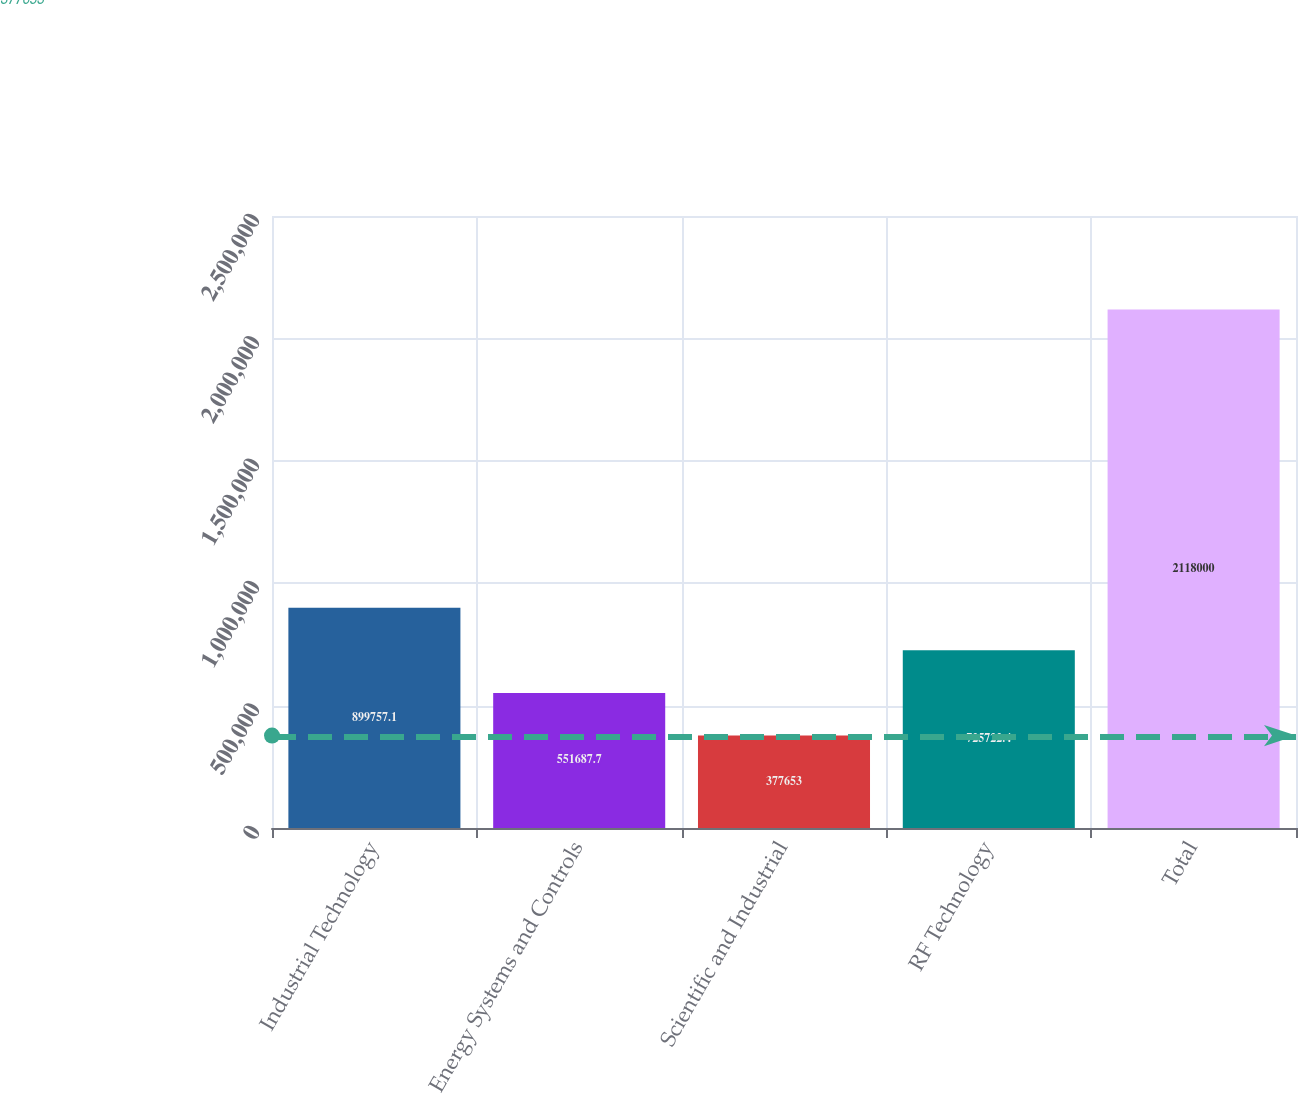Convert chart. <chart><loc_0><loc_0><loc_500><loc_500><bar_chart><fcel>Industrial Technology<fcel>Energy Systems and Controls<fcel>Scientific and Industrial<fcel>RF Technology<fcel>Total<nl><fcel>899757<fcel>551688<fcel>377653<fcel>725722<fcel>2.118e+06<nl></chart> 